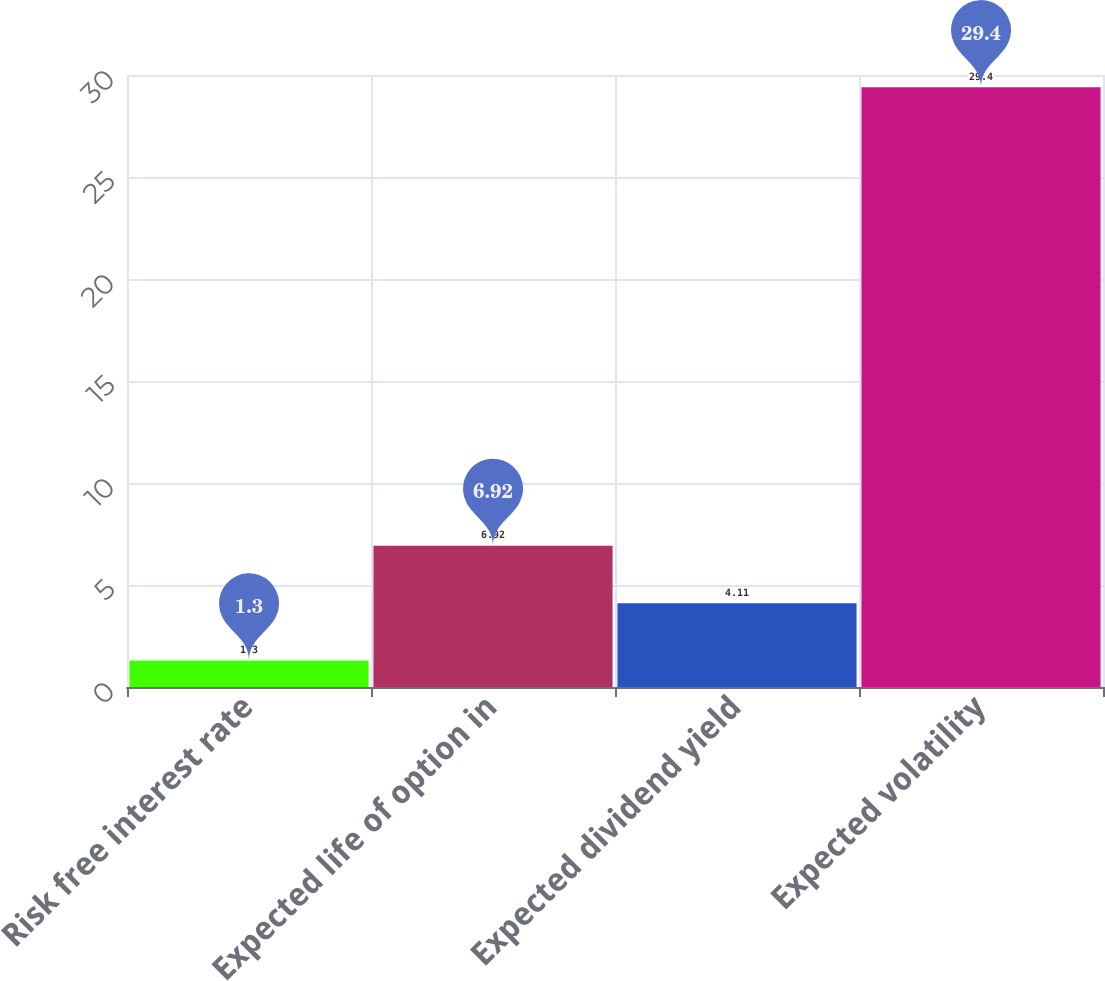<chart> <loc_0><loc_0><loc_500><loc_500><bar_chart><fcel>Risk free interest rate<fcel>Expected life of option in<fcel>Expected dividend yield<fcel>Expected volatility<nl><fcel>1.3<fcel>6.92<fcel>4.11<fcel>29.4<nl></chart> 